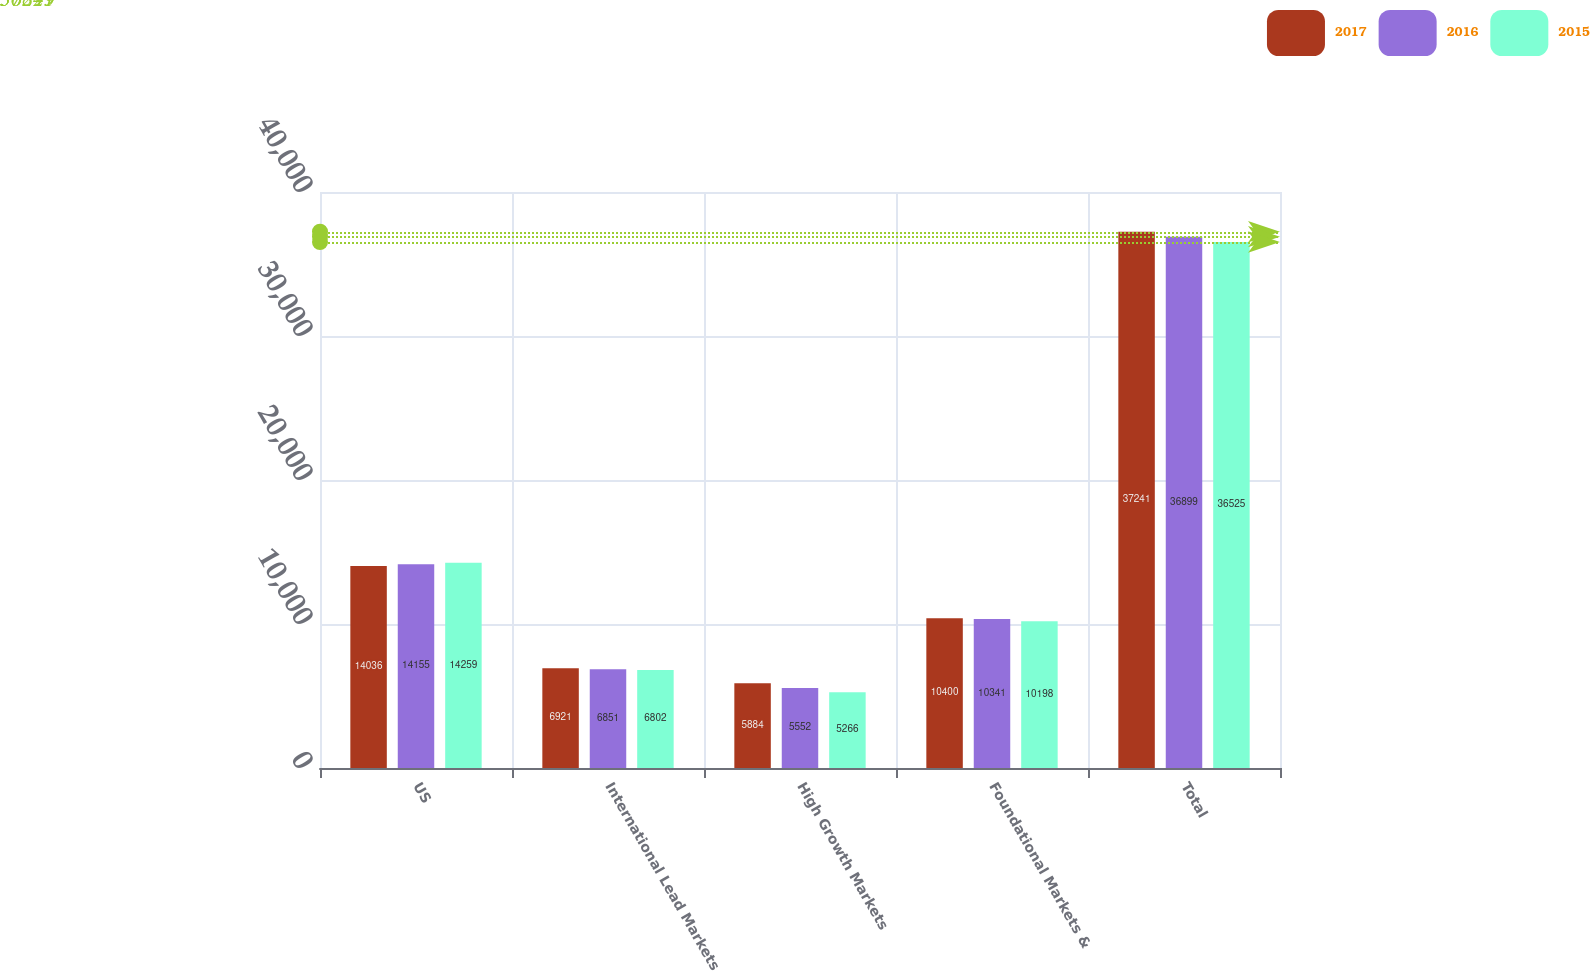<chart> <loc_0><loc_0><loc_500><loc_500><stacked_bar_chart><ecel><fcel>US<fcel>International Lead Markets<fcel>High Growth Markets<fcel>Foundational Markets &<fcel>Total<nl><fcel>2017<fcel>14036<fcel>6921<fcel>5884<fcel>10400<fcel>37241<nl><fcel>2016<fcel>14155<fcel>6851<fcel>5552<fcel>10341<fcel>36899<nl><fcel>2015<fcel>14259<fcel>6802<fcel>5266<fcel>10198<fcel>36525<nl></chart> 